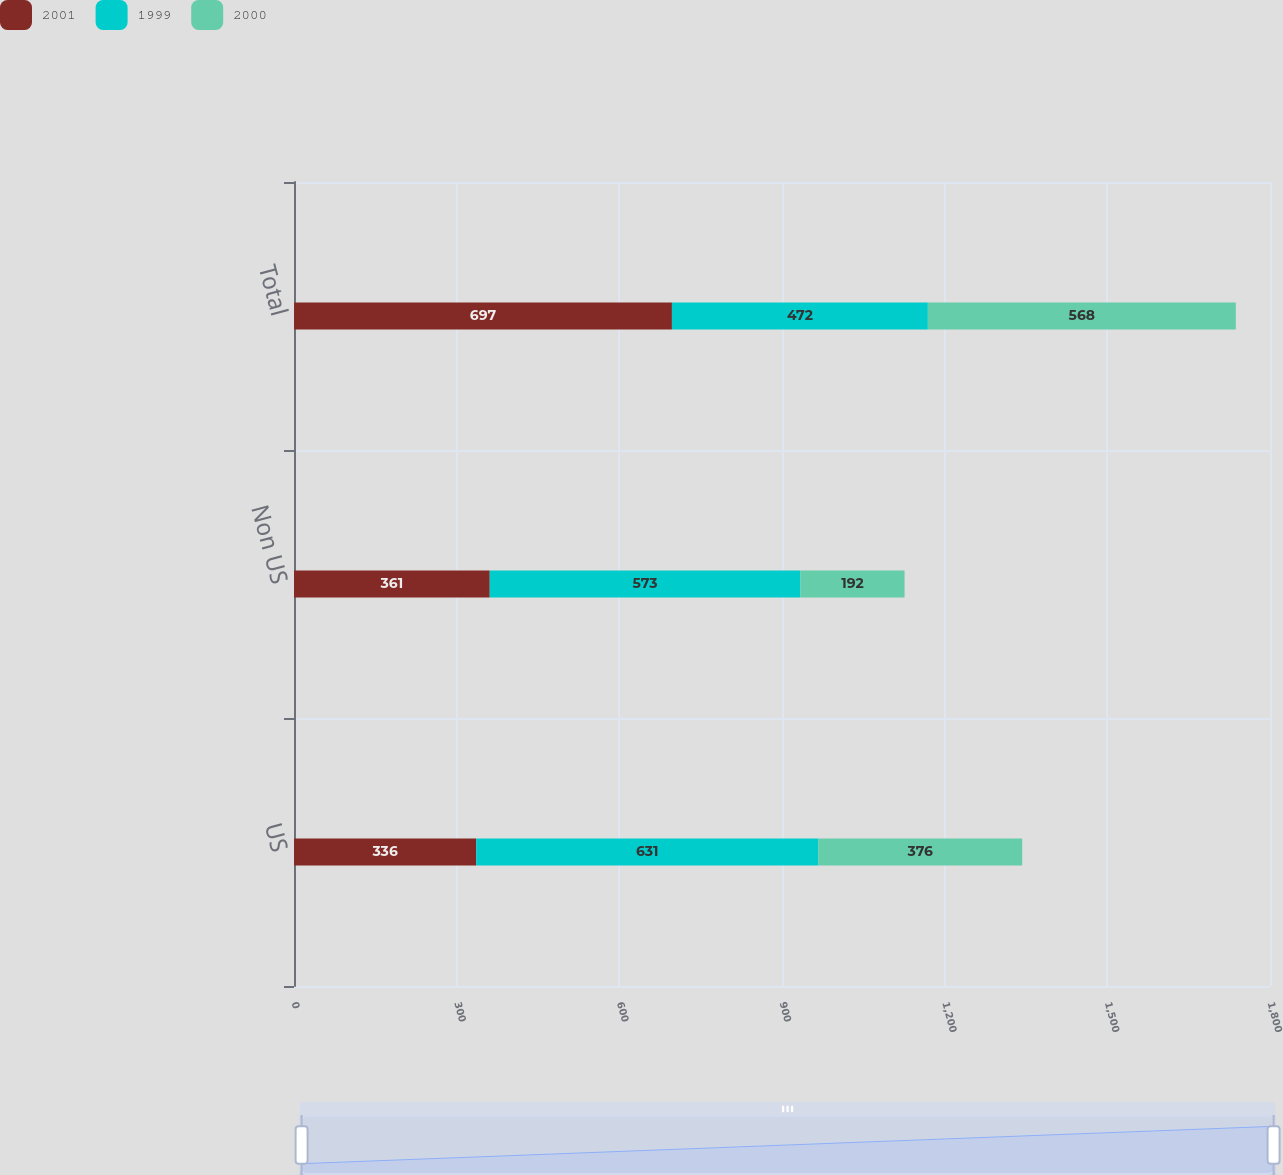Convert chart. <chart><loc_0><loc_0><loc_500><loc_500><stacked_bar_chart><ecel><fcel>US<fcel>Non US<fcel>Total<nl><fcel>2001<fcel>336<fcel>361<fcel>697<nl><fcel>1999<fcel>631<fcel>573<fcel>472<nl><fcel>2000<fcel>376<fcel>192<fcel>568<nl></chart> 